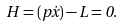<formula> <loc_0><loc_0><loc_500><loc_500>H = ( p \dot { x } ) - L = 0 .</formula> 